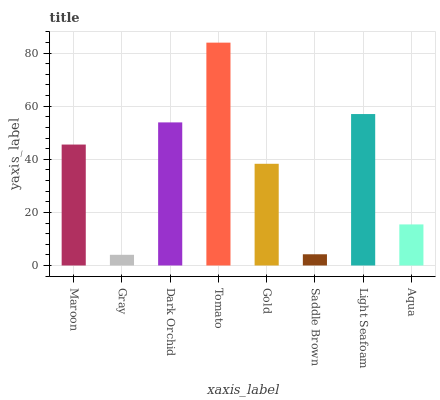Is Tomato the maximum?
Answer yes or no. Yes. Is Dark Orchid the minimum?
Answer yes or no. No. Is Dark Orchid the maximum?
Answer yes or no. No. Is Dark Orchid greater than Gray?
Answer yes or no. Yes. Is Gray less than Dark Orchid?
Answer yes or no. Yes. Is Gray greater than Dark Orchid?
Answer yes or no. No. Is Dark Orchid less than Gray?
Answer yes or no. No. Is Maroon the high median?
Answer yes or no. Yes. Is Gold the low median?
Answer yes or no. Yes. Is Aqua the high median?
Answer yes or no. No. Is Maroon the low median?
Answer yes or no. No. 